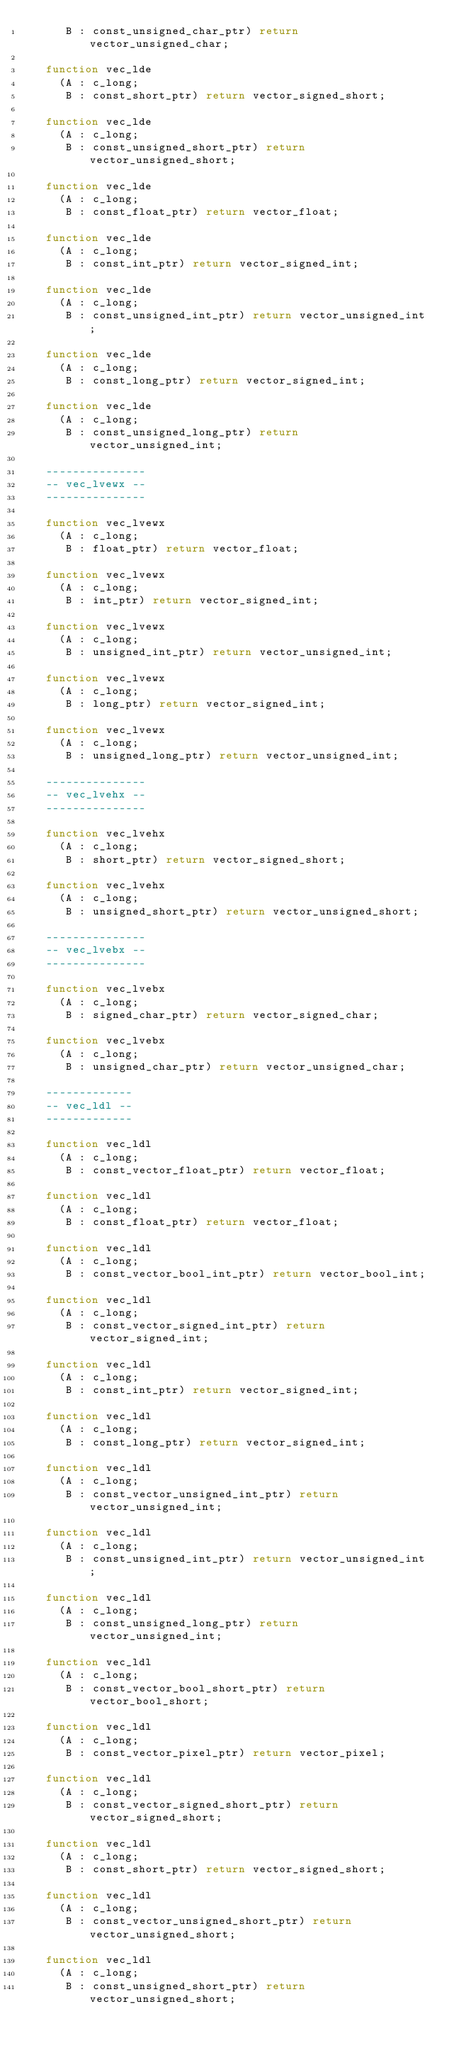<code> <loc_0><loc_0><loc_500><loc_500><_Ada_>      B : const_unsigned_char_ptr) return vector_unsigned_char;

   function vec_lde
     (A : c_long;
      B : const_short_ptr) return vector_signed_short;

   function vec_lde
     (A : c_long;
      B : const_unsigned_short_ptr) return vector_unsigned_short;

   function vec_lde
     (A : c_long;
      B : const_float_ptr) return vector_float;

   function vec_lde
     (A : c_long;
      B : const_int_ptr) return vector_signed_int;

   function vec_lde
     (A : c_long;
      B : const_unsigned_int_ptr) return vector_unsigned_int;

   function vec_lde
     (A : c_long;
      B : const_long_ptr) return vector_signed_int;

   function vec_lde
     (A : c_long;
      B : const_unsigned_long_ptr) return vector_unsigned_int;

   ---------------
   -- vec_lvewx --
   ---------------

   function vec_lvewx
     (A : c_long;
      B : float_ptr) return vector_float;

   function vec_lvewx
     (A : c_long;
      B : int_ptr) return vector_signed_int;

   function vec_lvewx
     (A : c_long;
      B : unsigned_int_ptr) return vector_unsigned_int;

   function vec_lvewx
     (A : c_long;
      B : long_ptr) return vector_signed_int;

   function vec_lvewx
     (A : c_long;
      B : unsigned_long_ptr) return vector_unsigned_int;

   ---------------
   -- vec_lvehx --
   ---------------

   function vec_lvehx
     (A : c_long;
      B : short_ptr) return vector_signed_short;

   function vec_lvehx
     (A : c_long;
      B : unsigned_short_ptr) return vector_unsigned_short;

   ---------------
   -- vec_lvebx --
   ---------------

   function vec_lvebx
     (A : c_long;
      B : signed_char_ptr) return vector_signed_char;

   function vec_lvebx
     (A : c_long;
      B : unsigned_char_ptr) return vector_unsigned_char;

   -------------
   -- vec_ldl --
   -------------

   function vec_ldl
     (A : c_long;
      B : const_vector_float_ptr) return vector_float;

   function vec_ldl
     (A : c_long;
      B : const_float_ptr) return vector_float;

   function vec_ldl
     (A : c_long;
      B : const_vector_bool_int_ptr) return vector_bool_int;

   function vec_ldl
     (A : c_long;
      B : const_vector_signed_int_ptr) return vector_signed_int;

   function vec_ldl
     (A : c_long;
      B : const_int_ptr) return vector_signed_int;

   function vec_ldl
     (A : c_long;
      B : const_long_ptr) return vector_signed_int;

   function vec_ldl
     (A : c_long;
      B : const_vector_unsigned_int_ptr) return vector_unsigned_int;

   function vec_ldl
     (A : c_long;
      B : const_unsigned_int_ptr) return vector_unsigned_int;

   function vec_ldl
     (A : c_long;
      B : const_unsigned_long_ptr) return vector_unsigned_int;

   function vec_ldl
     (A : c_long;
      B : const_vector_bool_short_ptr) return vector_bool_short;

   function vec_ldl
     (A : c_long;
      B : const_vector_pixel_ptr) return vector_pixel;

   function vec_ldl
     (A : c_long;
      B : const_vector_signed_short_ptr) return vector_signed_short;

   function vec_ldl
     (A : c_long;
      B : const_short_ptr) return vector_signed_short;

   function vec_ldl
     (A : c_long;
      B : const_vector_unsigned_short_ptr) return vector_unsigned_short;

   function vec_ldl
     (A : c_long;
      B : const_unsigned_short_ptr) return vector_unsigned_short;
</code> 